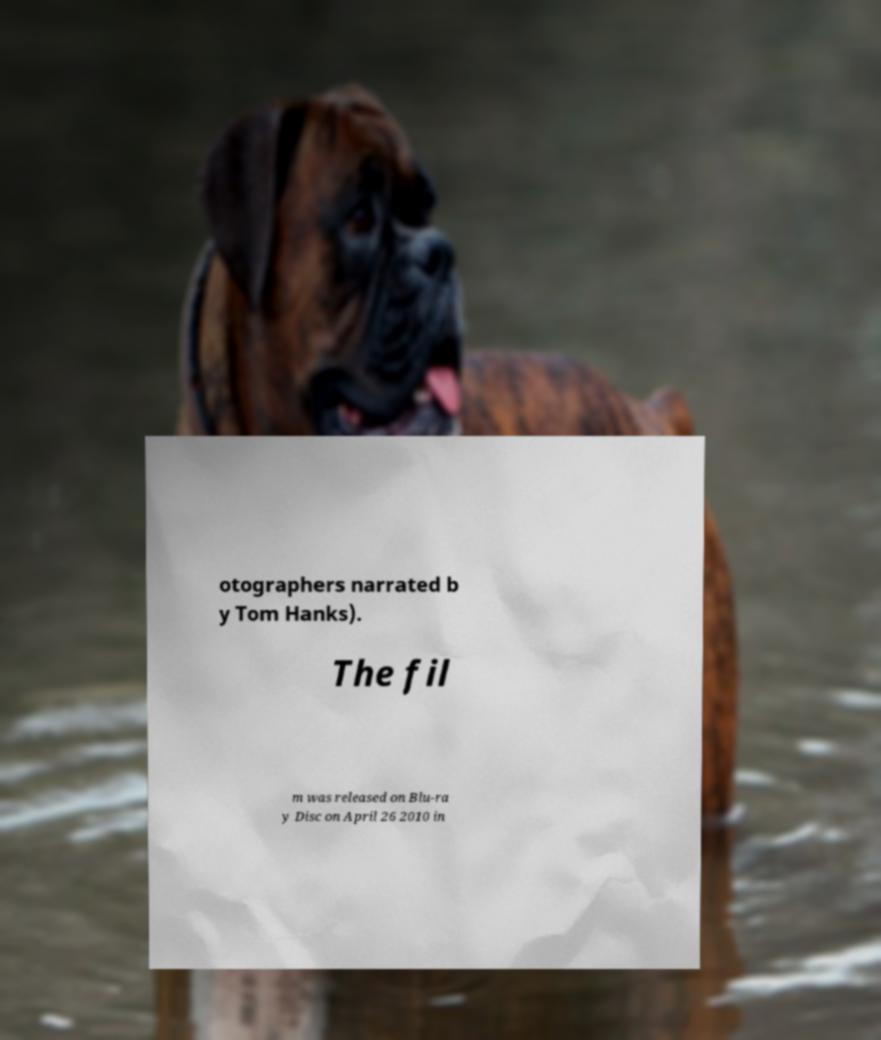Can you accurately transcribe the text from the provided image for me? otographers narrated b y Tom Hanks). The fil m was released on Blu-ra y Disc on April 26 2010 in 